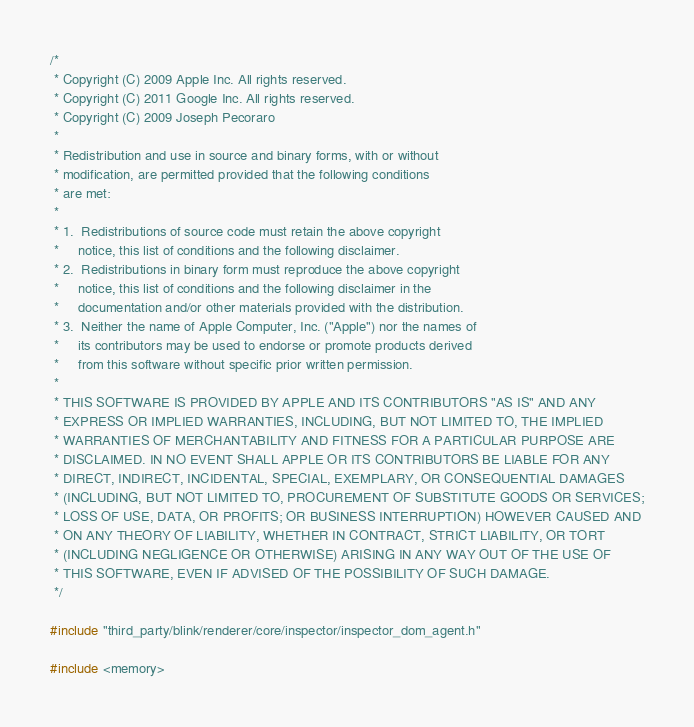Convert code to text. <code><loc_0><loc_0><loc_500><loc_500><_C++_>/*
 * Copyright (C) 2009 Apple Inc. All rights reserved.
 * Copyright (C) 2011 Google Inc. All rights reserved.
 * Copyright (C) 2009 Joseph Pecoraro
 *
 * Redistribution and use in source and binary forms, with or without
 * modification, are permitted provided that the following conditions
 * are met:
 *
 * 1.  Redistributions of source code must retain the above copyright
 *     notice, this list of conditions and the following disclaimer.
 * 2.  Redistributions in binary form must reproduce the above copyright
 *     notice, this list of conditions and the following disclaimer in the
 *     documentation and/or other materials provided with the distribution.
 * 3.  Neither the name of Apple Computer, Inc. ("Apple") nor the names of
 *     its contributors may be used to endorse or promote products derived
 *     from this software without specific prior written permission.
 *
 * THIS SOFTWARE IS PROVIDED BY APPLE AND ITS CONTRIBUTORS "AS IS" AND ANY
 * EXPRESS OR IMPLIED WARRANTIES, INCLUDING, BUT NOT LIMITED TO, THE IMPLIED
 * WARRANTIES OF MERCHANTABILITY AND FITNESS FOR A PARTICULAR PURPOSE ARE
 * DISCLAIMED. IN NO EVENT SHALL APPLE OR ITS CONTRIBUTORS BE LIABLE FOR ANY
 * DIRECT, INDIRECT, INCIDENTAL, SPECIAL, EXEMPLARY, OR CONSEQUENTIAL DAMAGES
 * (INCLUDING, BUT NOT LIMITED TO, PROCUREMENT OF SUBSTITUTE GOODS OR SERVICES;
 * LOSS OF USE, DATA, OR PROFITS; OR BUSINESS INTERRUPTION) HOWEVER CAUSED AND
 * ON ANY THEORY OF LIABILITY, WHETHER IN CONTRACT, STRICT LIABILITY, OR TORT
 * (INCLUDING NEGLIGENCE OR OTHERWISE) ARISING IN ANY WAY OUT OF THE USE OF
 * THIS SOFTWARE, EVEN IF ADVISED OF THE POSSIBILITY OF SUCH DAMAGE.
 */

#include "third_party/blink/renderer/core/inspector/inspector_dom_agent.h"

#include <memory></code> 